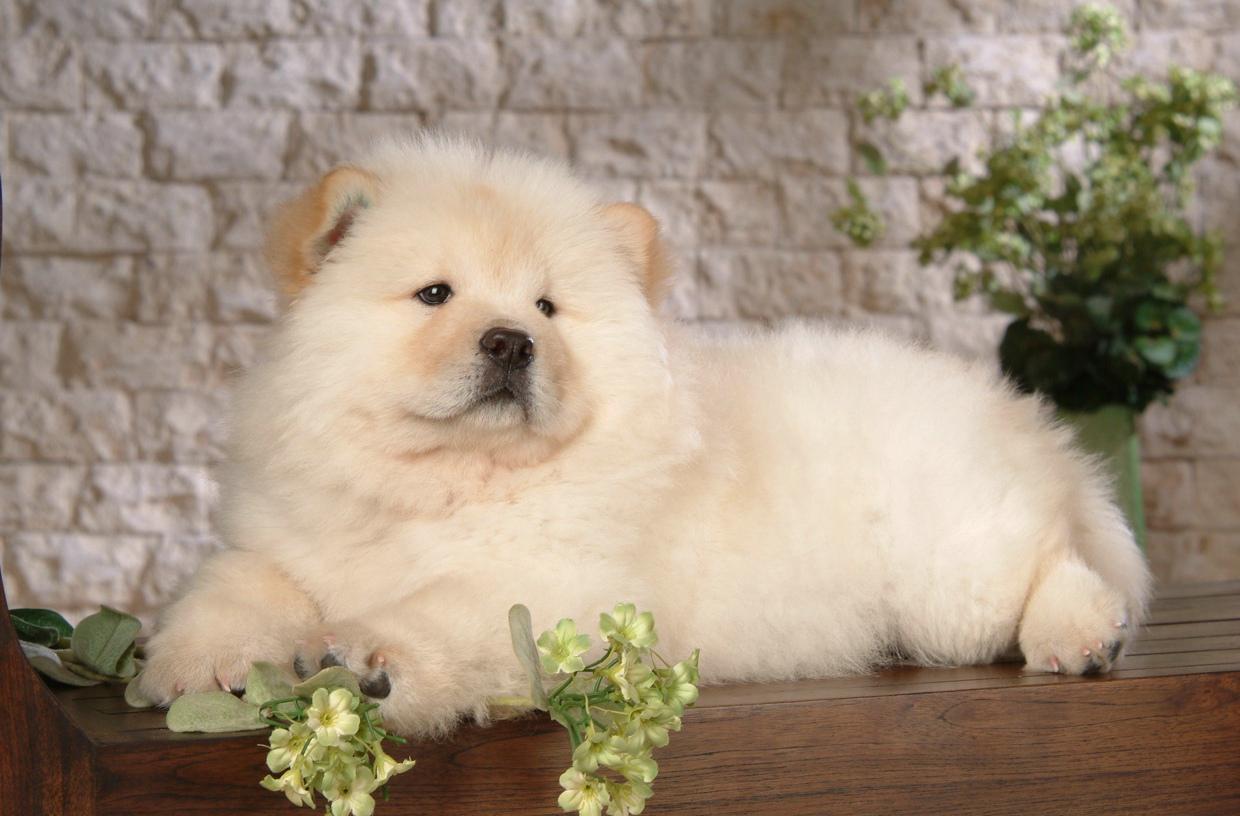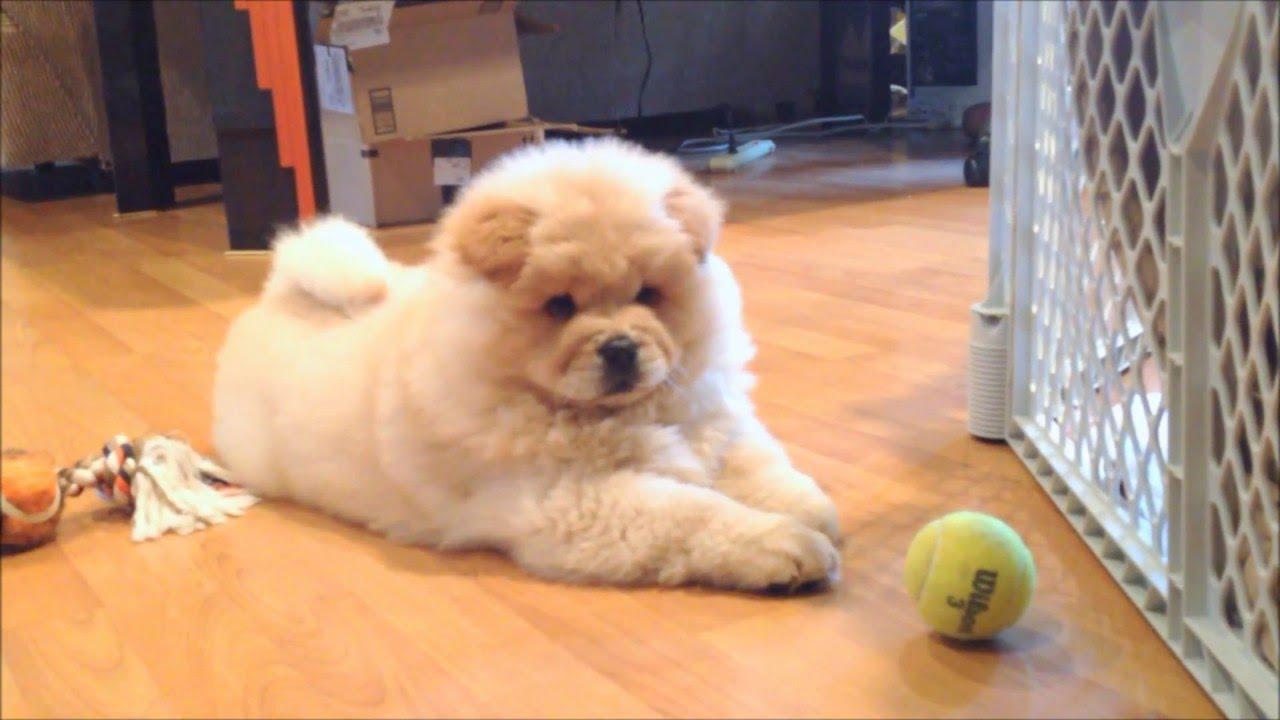The first image is the image on the left, the second image is the image on the right. Considering the images on both sides, is "a brick wall is behind a dog." valid? Answer yes or no. Yes. 